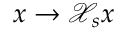Convert formula to latex. <formula><loc_0><loc_0><loc_500><loc_500>x \rightarrow \mathcal { X } _ { s } { x }</formula> 